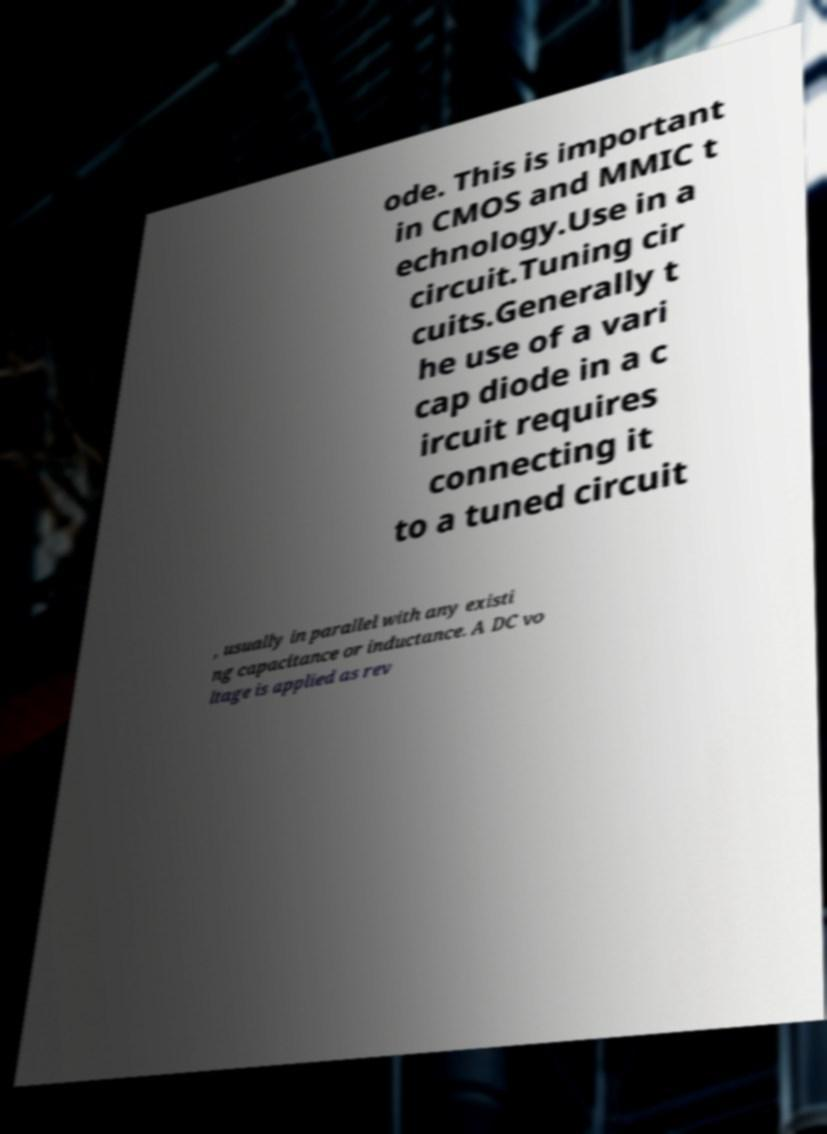Please read and relay the text visible in this image. What does it say? ode. This is important in CMOS and MMIC t echnology.Use in a circuit.Tuning cir cuits.Generally t he use of a vari cap diode in a c ircuit requires connecting it to a tuned circuit , usually in parallel with any existi ng capacitance or inductance. A DC vo ltage is applied as rev 